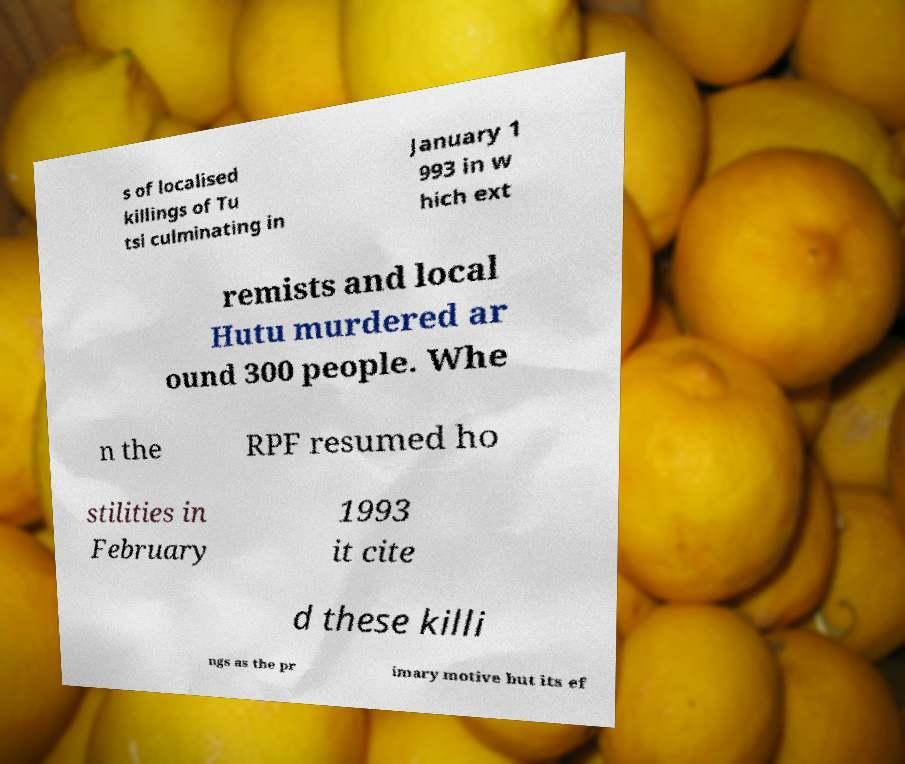Can you read and provide the text displayed in the image?This photo seems to have some interesting text. Can you extract and type it out for me? s of localised killings of Tu tsi culminating in January 1 993 in w hich ext remists and local Hutu murdered ar ound 300 people. Whe n the RPF resumed ho stilities in February 1993 it cite d these killi ngs as the pr imary motive but its ef 